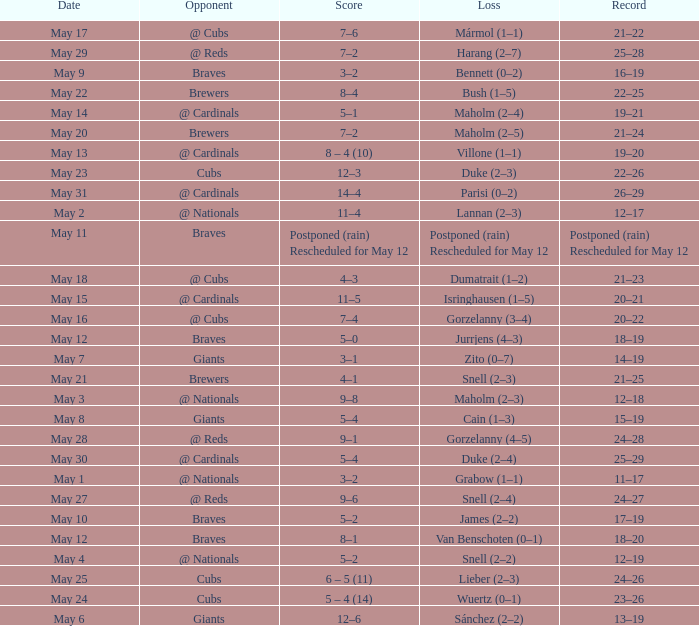What was the date of the game with a loss of Bush (1–5)? May 22. 